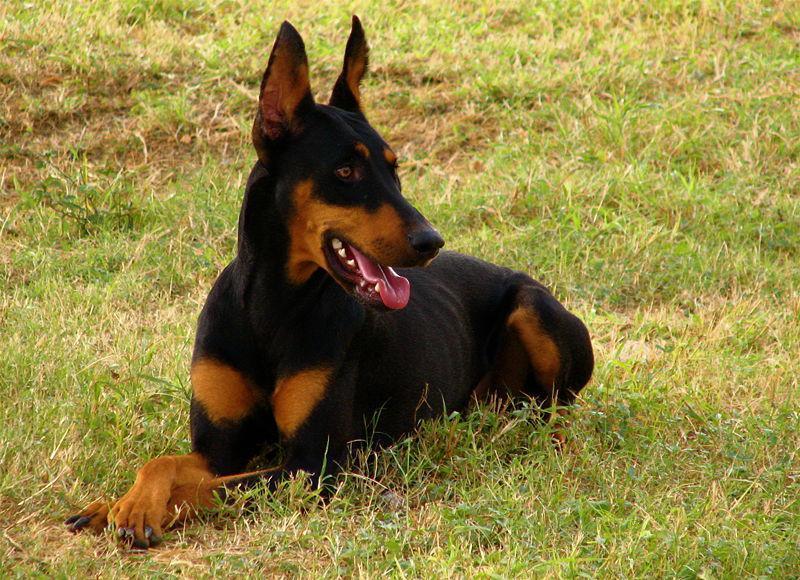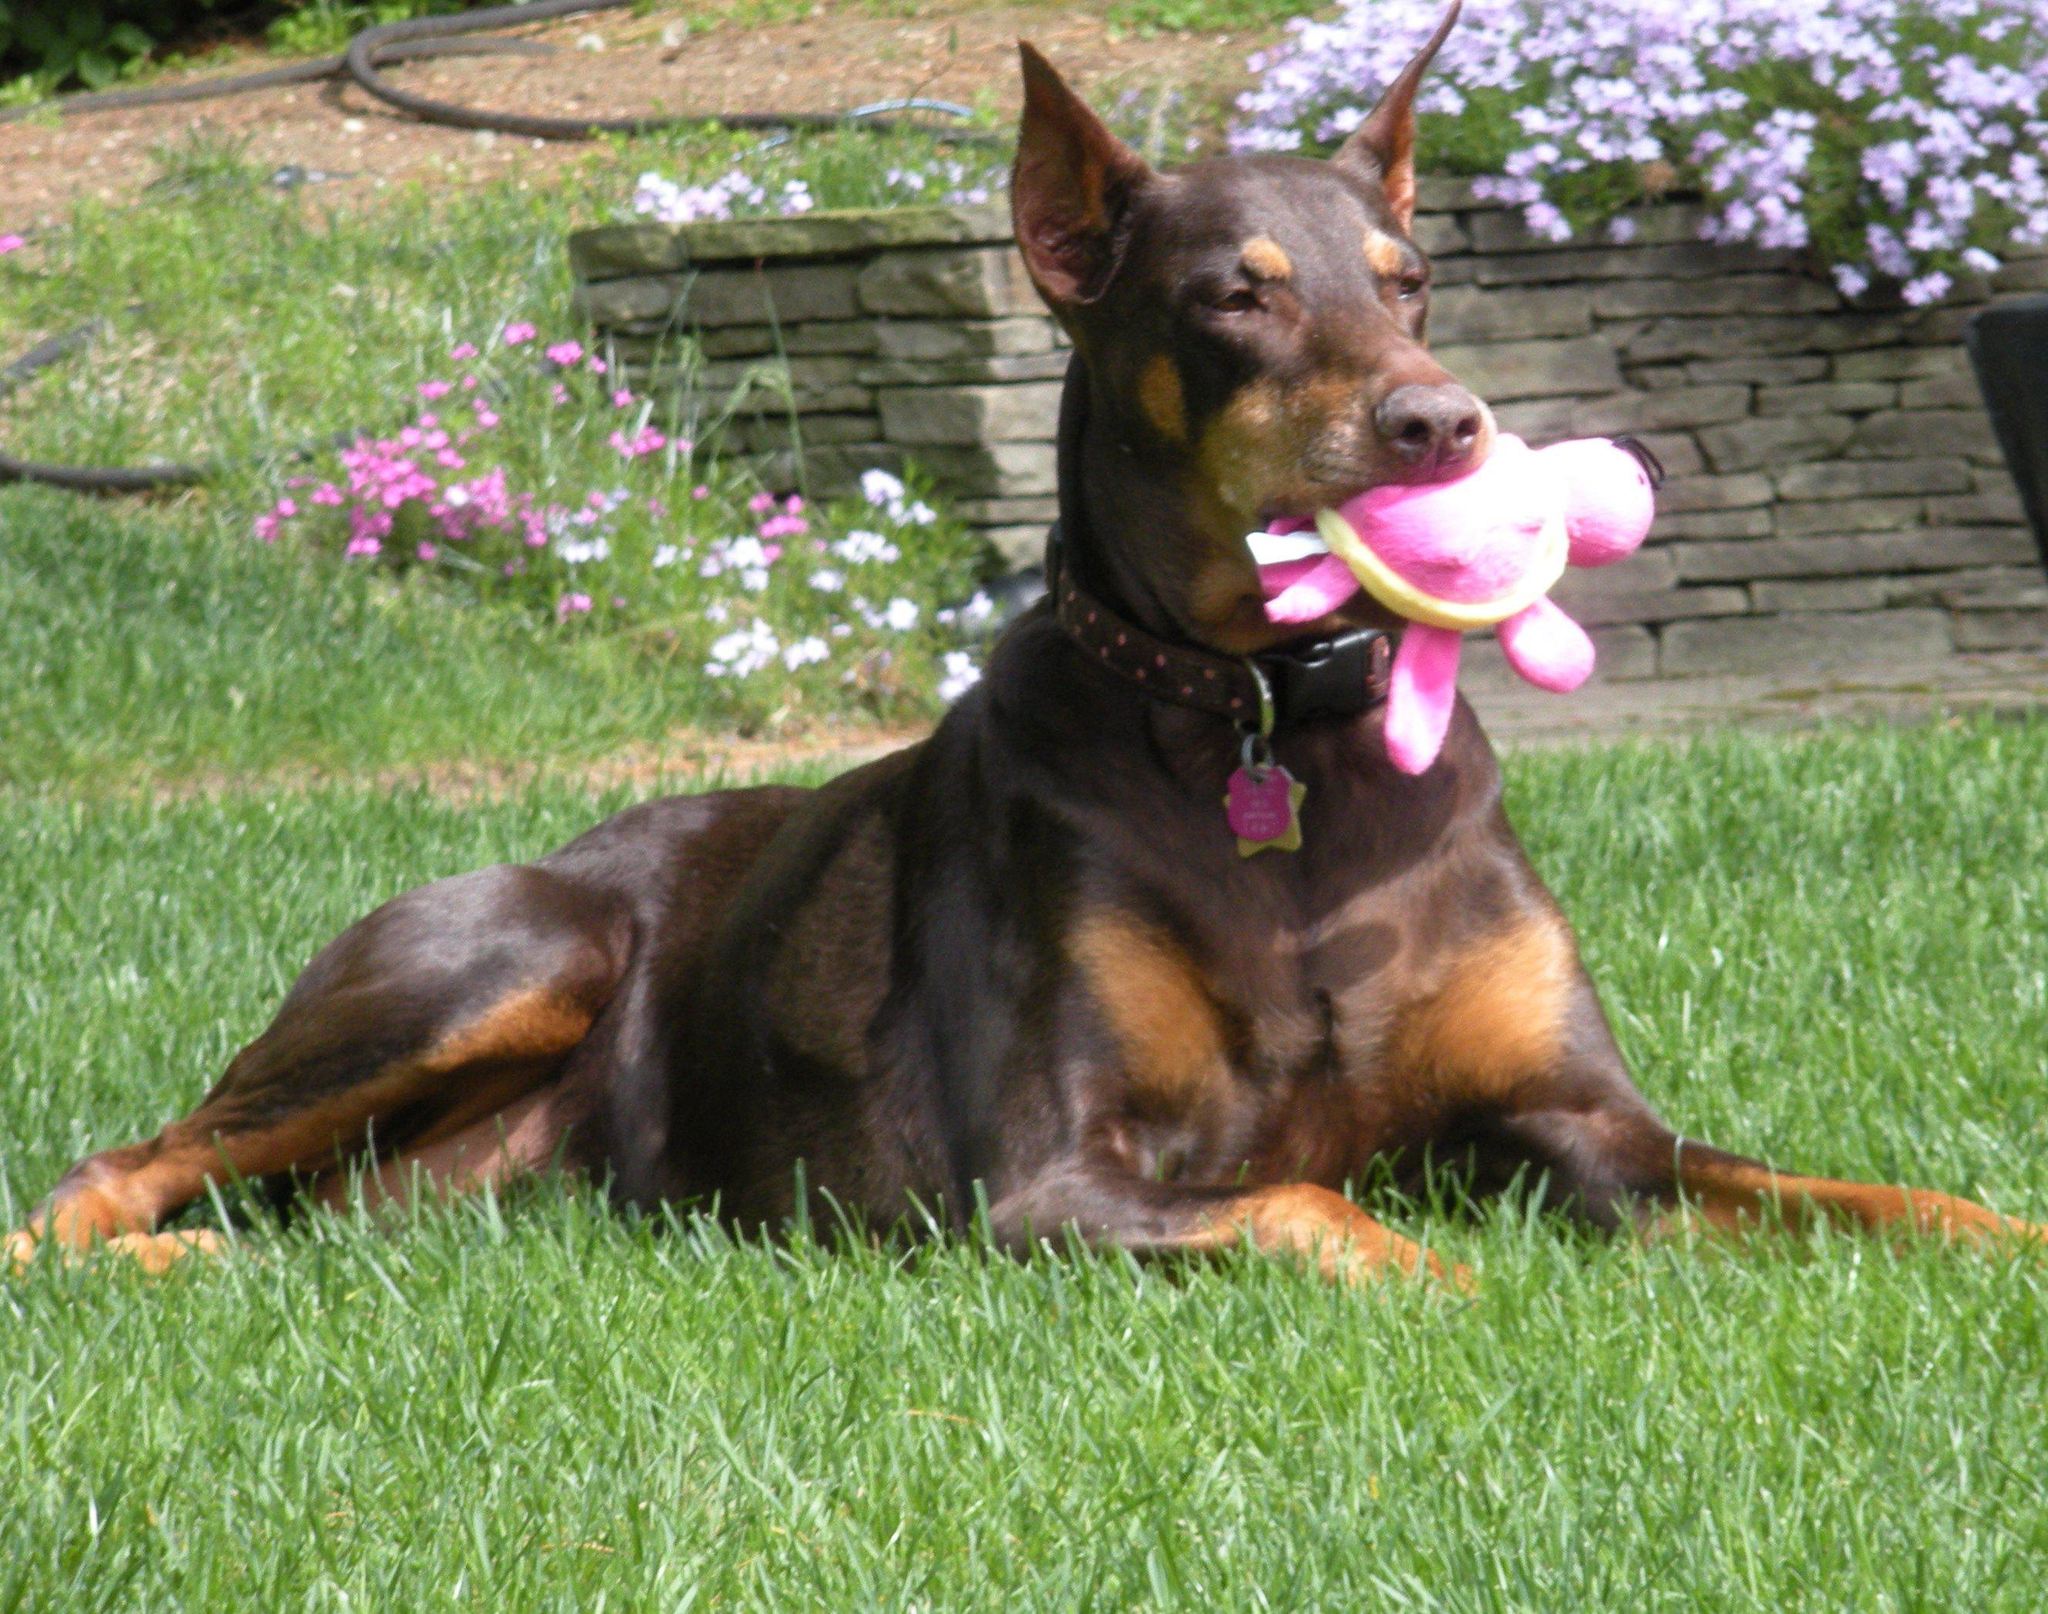The first image is the image on the left, the second image is the image on the right. Given the left and right images, does the statement "One image shows a single dog lying on grass with its front paws extended and crossed." hold true? Answer yes or no. Yes. The first image is the image on the left, the second image is the image on the right. For the images shown, is this caption "One image contains one pointy-eared doberman in a reclining pose with upright head, and the other image features side-by-side pointy-eared dobermans - one brown and one black-and-tan." true? Answer yes or no. No. 